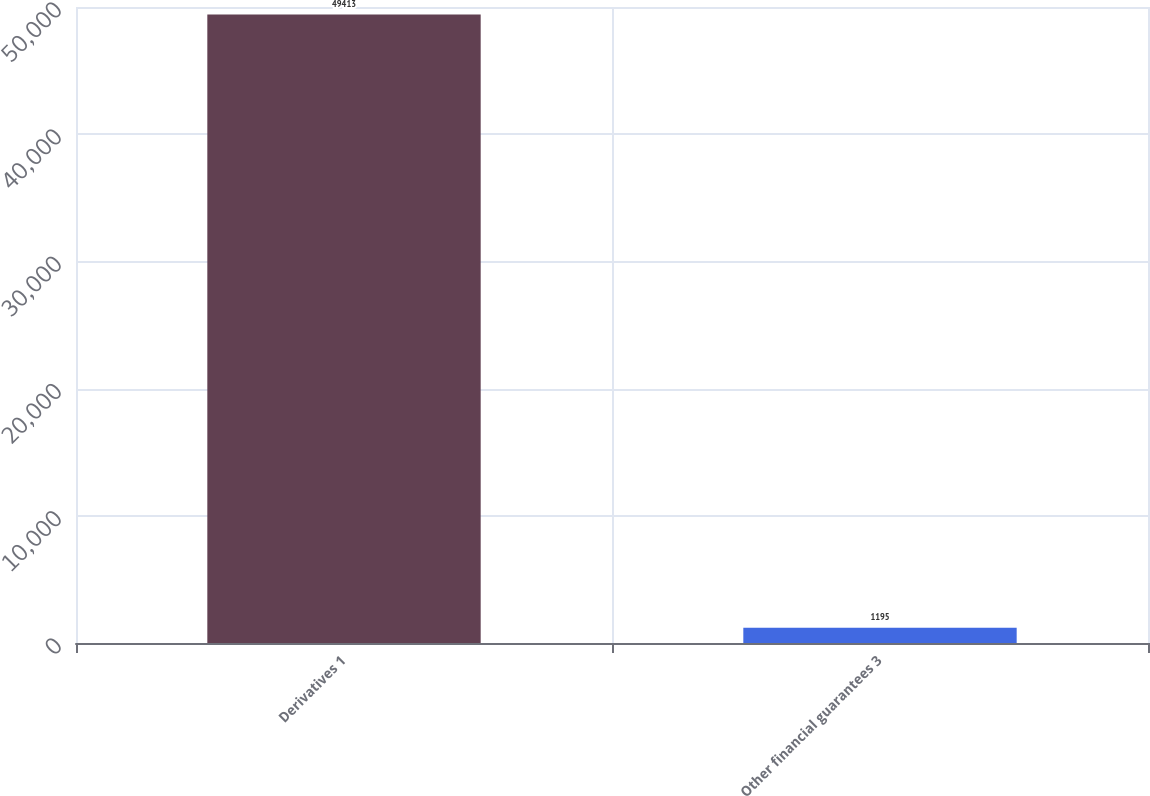Convert chart. <chart><loc_0><loc_0><loc_500><loc_500><bar_chart><fcel>Derivatives 1<fcel>Other financial guarantees 3<nl><fcel>49413<fcel>1195<nl></chart> 